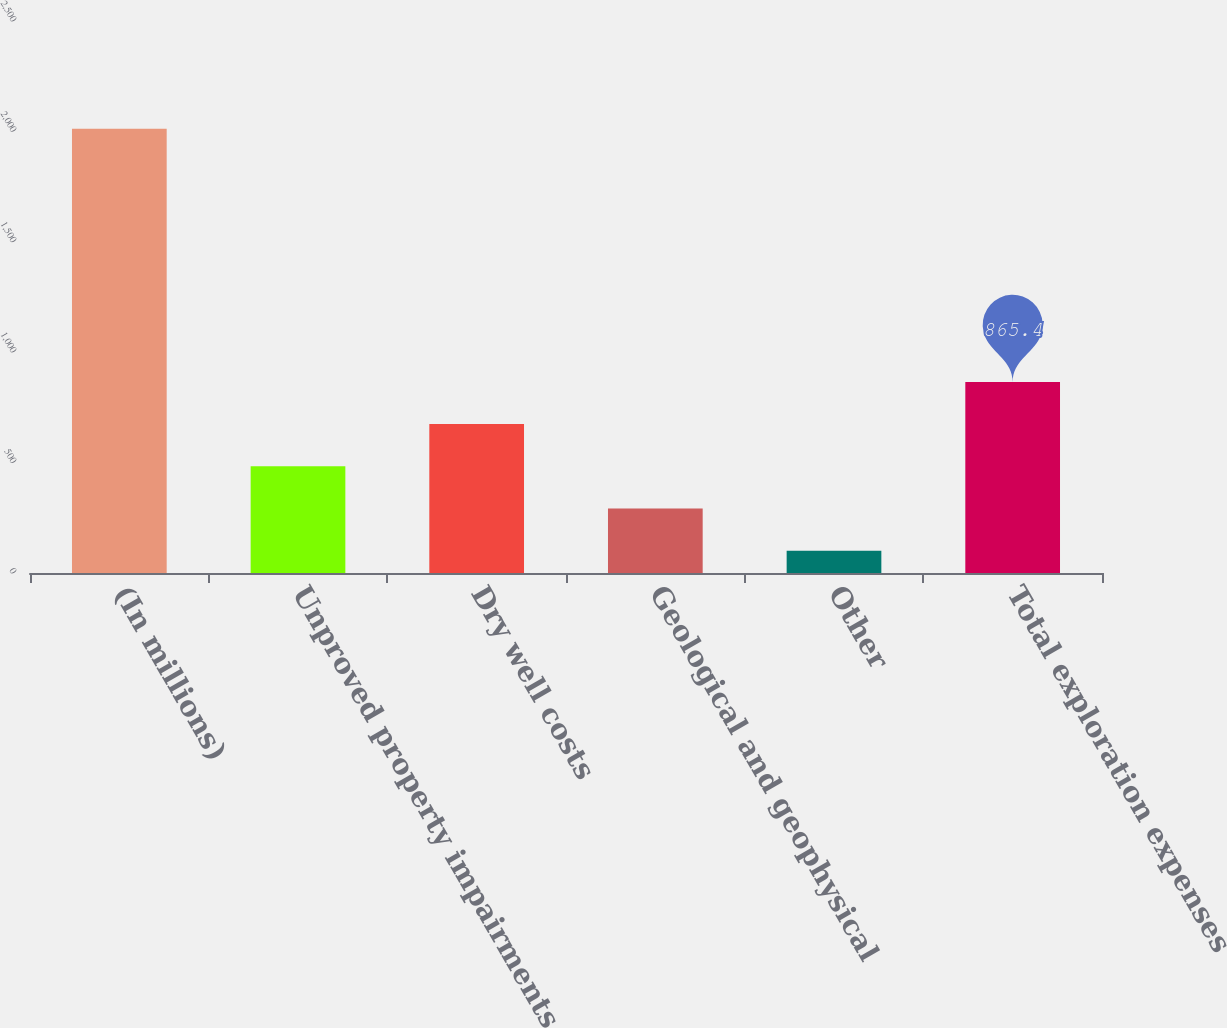<chart> <loc_0><loc_0><loc_500><loc_500><bar_chart><fcel>(In millions)<fcel>Unproved property impairments<fcel>Dry well costs<fcel>Geological and geophysical<fcel>Other<fcel>Total exploration expenses<nl><fcel>2012<fcel>483.2<fcel>674.3<fcel>292.1<fcel>101<fcel>865.4<nl></chart> 